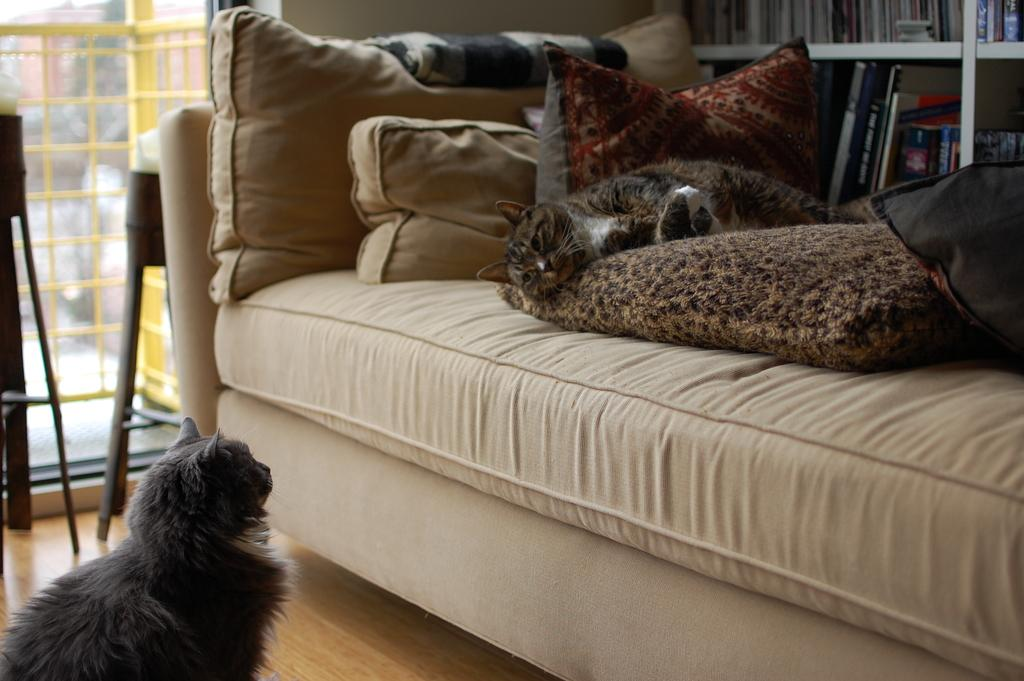What type of animal can be seen on the floor in the image? There is a cat on the floor in the image. Where is the second cat located in the image? The second cat is on a couch in the image. What type of furniture is visible in the image? There are pillows visible in the image. What can be seen in the background of the image? There are books in a rack and a wall in the image. What type of cloth is the cat using to join the class in the image? There is no cloth or class present in the image; it features two cats, pillows, books in a rack, a wall. 